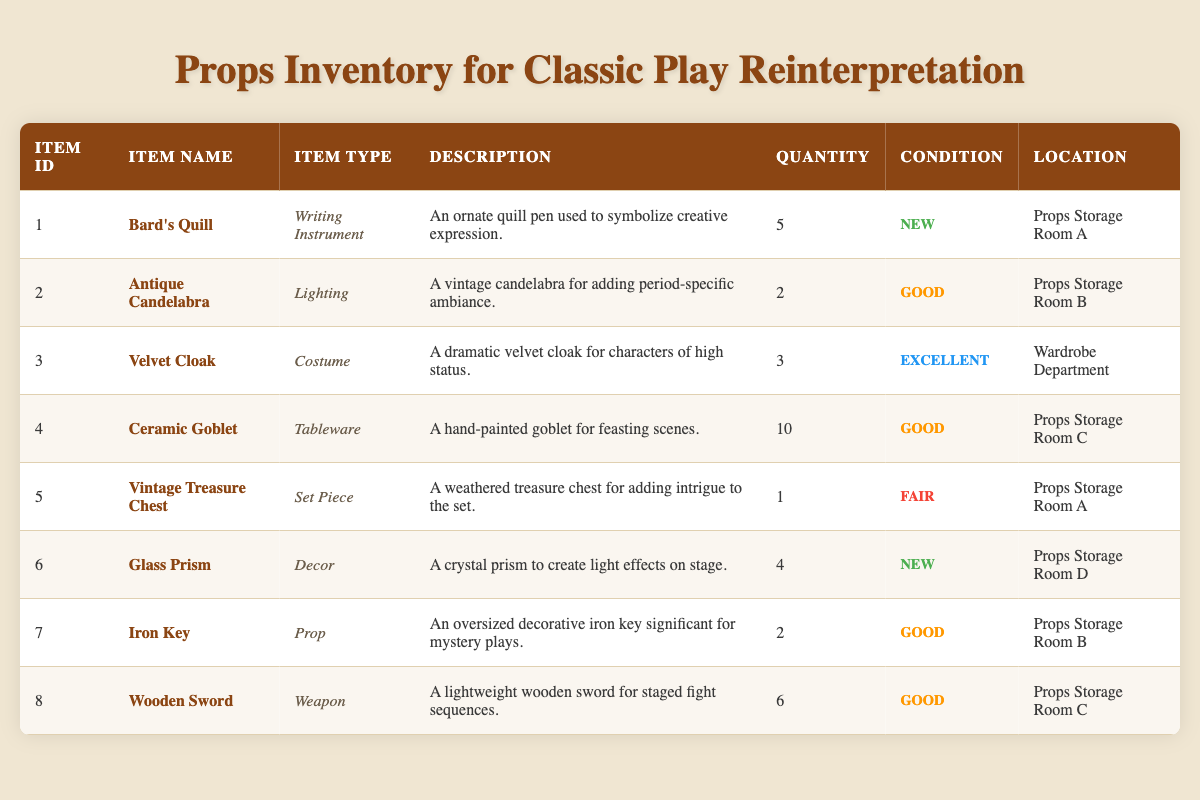What is the total quantity of all the props listed in the inventory? To find the total quantity, we add up the quantities of all items: 5 (Bard's Quill) + 2 (Antique Candelabra) + 3 (Velvet Cloak) + 10 (Ceramic Goblet) + 1 (Vintage Treasure Chest) + 4 (Glass Prism) + 2 (Iron Key) + 6 (Wooden Sword) = 33.
Answer: 33 How many items are in 'Good' condition? The items listed in 'Good' condition are: Antique Candelabra, Ceramic Goblet, Iron Key, and Wooden Sword, totaling 4 items.
Answer: 4 Is the Velvet Cloak stored in Props Storage Room C? The Velvet Cloak is located in the Wardrobe Department, so it is not stored in Props Storage Room C.
Answer: No What type of props has the most quantity? The Ceramic Goblet has the highest quantity with 10 items.
Answer: Ceramic Goblet Which item has the highest value in terms of condition? The Velvet Cloak is categorized as 'Excellent' condition, which is the highest value among the items listed.
Answer: Velvet Cloak How many items are categorized as set pieces, and what is the only one listed? Only one item is categorized as a set piece, which is the Vintage Treasure Chest found in Props Storage Room A.
Answer: 1 item, Vintage Treasure Chest True or False: There are more items in 'New' condition than those in 'Good' condition. There are 5 items in 'New' condition (Bard's Quill, Glass Prism), while there are 4 in 'Good' condition, making the statement true.
Answer: True Which location contains the most props? Props Storage Room C has 10 items (Ceramic Goblet) while the others have fewer, so it contains the most props.
Answer: Props Storage Room C If we consider the total quantity of props in 'Excellent' and 'New' conditions, what is the total? The Velvet Cloak is the only item in 'Excellent' condition with a quantity of 3, and there are 9 items in 'New' condition (5 Bard's Quill + 4 Glass Prism), summing up 3 + 9 = 12.
Answer: 12 